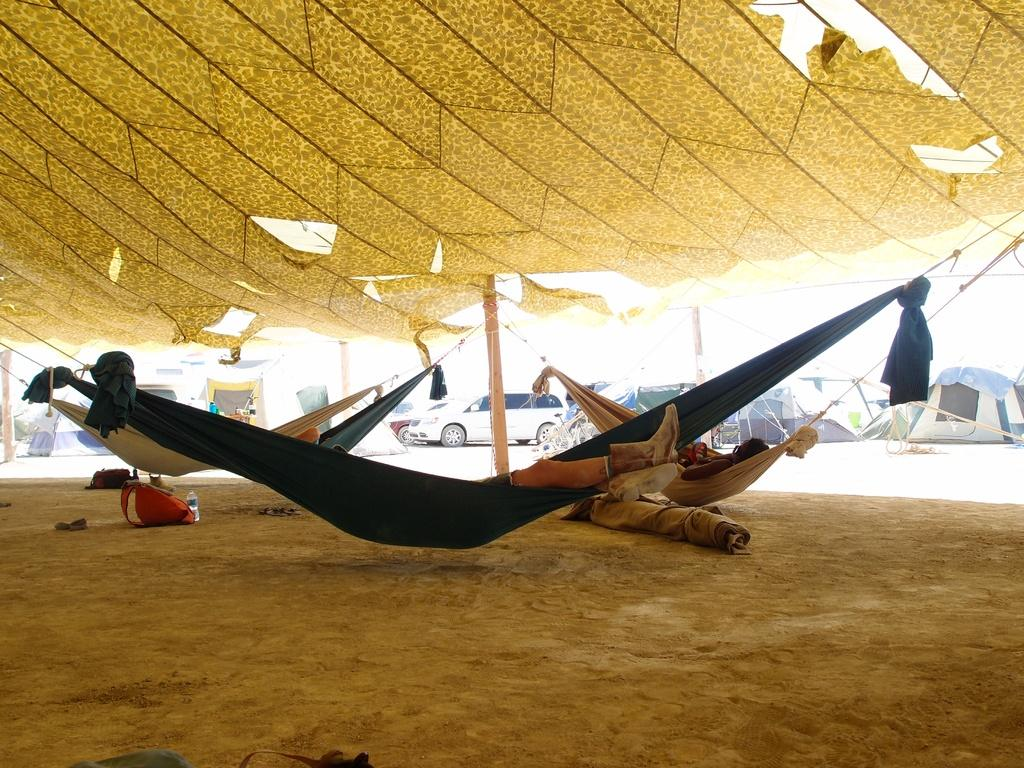What are the people in the swing doing? The people in the swing are sleeping. What type of temporary shelters can be seen in the image? There are tents in the image. What can be seen in the background of the image? There is a car in the background of the image. What objects are on the ground in the image? There is a bottle, a bag, and a cloth on the ground. What type of veil is draped over the sleeping people in the swing? There is no veil present in the image; the people are sleeping in a swing without any coverings. Do the sleeping people have fangs in the image? There is no indication of fangs on the sleeping people in the image. 